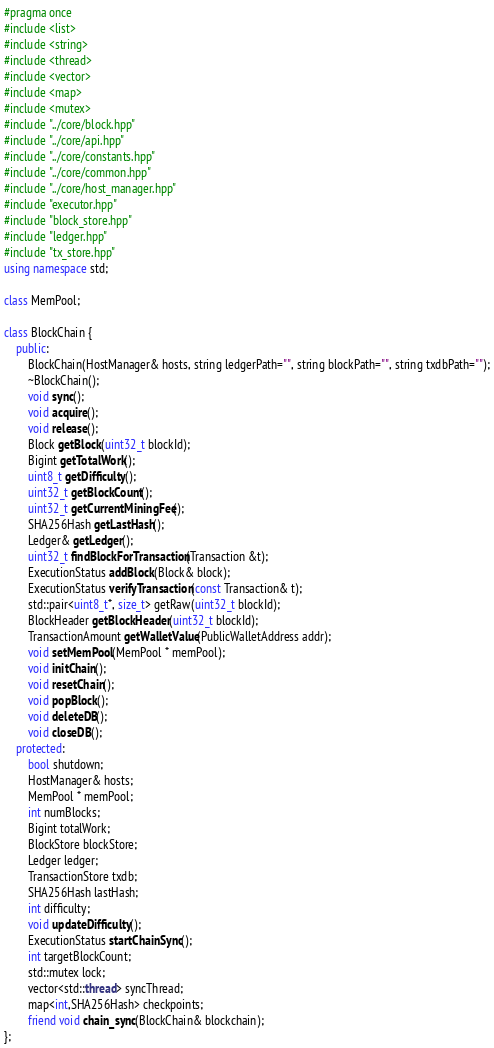<code> <loc_0><loc_0><loc_500><loc_500><_C++_>#pragma once
#include <list>
#include <string>
#include <thread>
#include <vector>
#include <map>
#include <mutex>
#include "../core/block.hpp"
#include "../core/api.hpp"
#include "../core/constants.hpp"
#include "../core/common.hpp"
#include "../core/host_manager.hpp"
#include "executor.hpp"
#include "block_store.hpp"
#include "ledger.hpp"
#include "tx_store.hpp"
using namespace std;

class MemPool;

class BlockChain {
    public:
        BlockChain(HostManager& hosts, string ledgerPath="", string blockPath="", string txdbPath="");
        ~BlockChain();
        void sync();
        void acquire();
        void release();
        Block getBlock(uint32_t blockId);
        Bigint getTotalWork();
        uint8_t getDifficulty();
        uint32_t getBlockCount();
        uint32_t getCurrentMiningFee();
        SHA256Hash getLastHash();
        Ledger& getLedger();
        uint32_t findBlockForTransaction(Transaction &t);
        ExecutionStatus addBlock(Block& block);
        ExecutionStatus verifyTransaction(const Transaction& t);
        std::pair<uint8_t*, size_t> getRaw(uint32_t blockId);
        BlockHeader getBlockHeader(uint32_t blockId);
        TransactionAmount getWalletValue(PublicWalletAddress addr);
        void setMemPool(MemPool * memPool);
        void initChain();
        void resetChain();
        void popBlock();
        void deleteDB();
        void closeDB();
    protected:
        bool shutdown;
        HostManager& hosts;
        MemPool * memPool;
        int numBlocks;
        Bigint totalWork;
        BlockStore blockStore;
        Ledger ledger;
        TransactionStore txdb;
        SHA256Hash lastHash;
        int difficulty;
        void updateDifficulty();
        ExecutionStatus startChainSync();
        int targetBlockCount;
        std::mutex lock;
        vector<std::thread> syncThread;
        map<int,SHA256Hash> checkpoints;
        friend void chain_sync(BlockChain& blockchain);
};</code> 